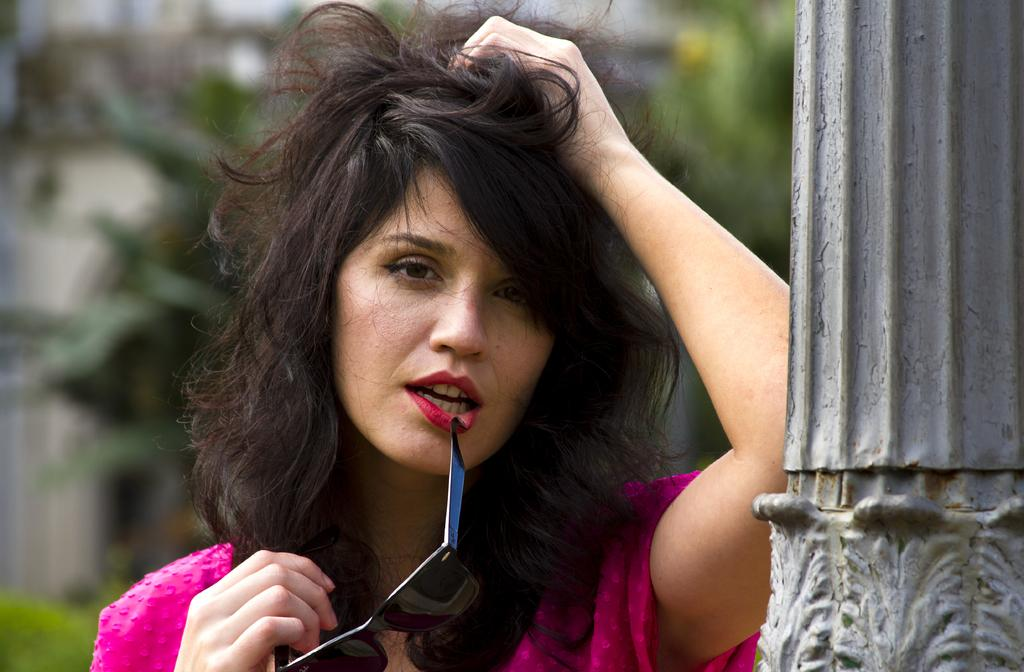Who is present in the image? There is a woman in the image. What is the woman doing in the image? The woman is standing in the image. What is the woman holding in her hand? The woman is holding sunglasses in her hand. What can be seen in the background of the image? There is a pillar in the image. Where is the woman standing in relation to the pillar? The woman is standing beside the pillar. What type of knee surgery is the woman undergoing in the image? There is no indication of a knee surgery or any medical procedure in the image; the woman is simply standing and holding sunglasses. 